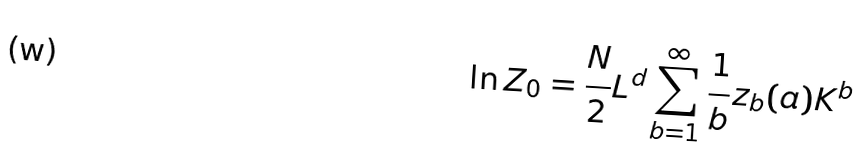Convert formula to latex. <formula><loc_0><loc_0><loc_500><loc_500>\ln Z _ { 0 } = \frac { N } { 2 } L ^ { d } \sum _ { b = 1 } ^ { \infty } \frac { 1 } { b } z _ { b } ( a ) K ^ { b }</formula> 